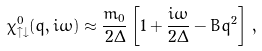<formula> <loc_0><loc_0><loc_500><loc_500>\chi ^ { 0 } _ { \uparrow \downarrow } ( q , i \omega ) \approx \frac { m _ { 0 } } { 2 \Delta } \left [ 1 + \frac { i \omega } { 2 \Delta } - B q ^ { 2 } \right ] \, ,</formula> 